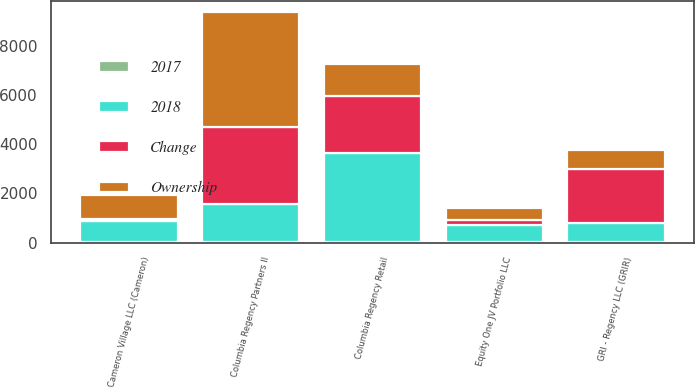Convert chart. <chart><loc_0><loc_0><loc_500><loc_500><stacked_bar_chart><ecel><fcel>GRI - Regency LLC (GRIR)<fcel>Equity One JV Portfolio LLC<fcel>Columbia Regency Retail<fcel>Columbia Regency Partners II<fcel>Cameron Village LLC (Cameron)<nl><fcel>2017<fcel>40<fcel>30<fcel>20<fcel>20<fcel>30<nl><fcel>Ownership<fcel>768<fcel>490<fcel>1311<fcel>4673<fcel>943<nl><fcel>2018<fcel>768<fcel>686<fcel>3620<fcel>1530<fcel>850<nl><fcel>Change<fcel>2174<fcel>196<fcel>2309<fcel>3143<fcel>93<nl></chart> 